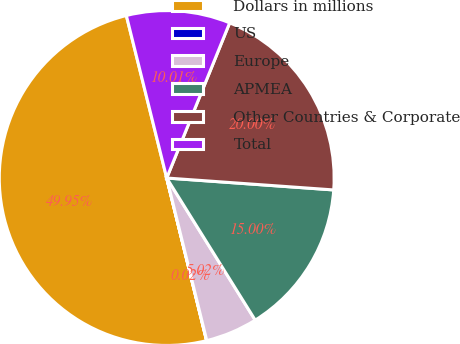<chart> <loc_0><loc_0><loc_500><loc_500><pie_chart><fcel>Dollars in millions<fcel>US<fcel>Europe<fcel>APMEA<fcel>Other Countries & Corporate<fcel>Total<nl><fcel>49.95%<fcel>0.02%<fcel>5.02%<fcel>15.0%<fcel>20.0%<fcel>10.01%<nl></chart> 